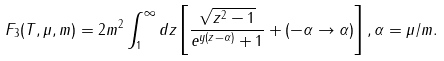Convert formula to latex. <formula><loc_0><loc_0><loc_500><loc_500>F _ { 3 } ( T , \mu , m ) = 2 m ^ { 2 } \int _ { 1 } ^ { \infty } d z \left [ \frac { \sqrt { z ^ { 2 } - 1 } } { e ^ { y ( z - \alpha ) } + 1 } + ( - \alpha \to \alpha ) \right ] , \alpha = \mu / m .</formula> 